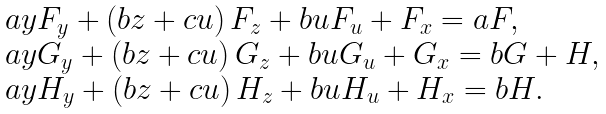<formula> <loc_0><loc_0><loc_500><loc_500>\begin{array} { l } a y F _ { y } + \left ( b z + c u \right ) F _ { z } + b u F _ { u } + F _ { x } = a F , \\ a y G _ { y } + \left ( b z + c u \right ) G _ { z } + b u G _ { u } + G _ { x } = b G + H , \\ a y H _ { y } + \left ( b z + c u \right ) H _ { z } + b u H _ { u } + H _ { x } = b H . \end{array}</formula> 